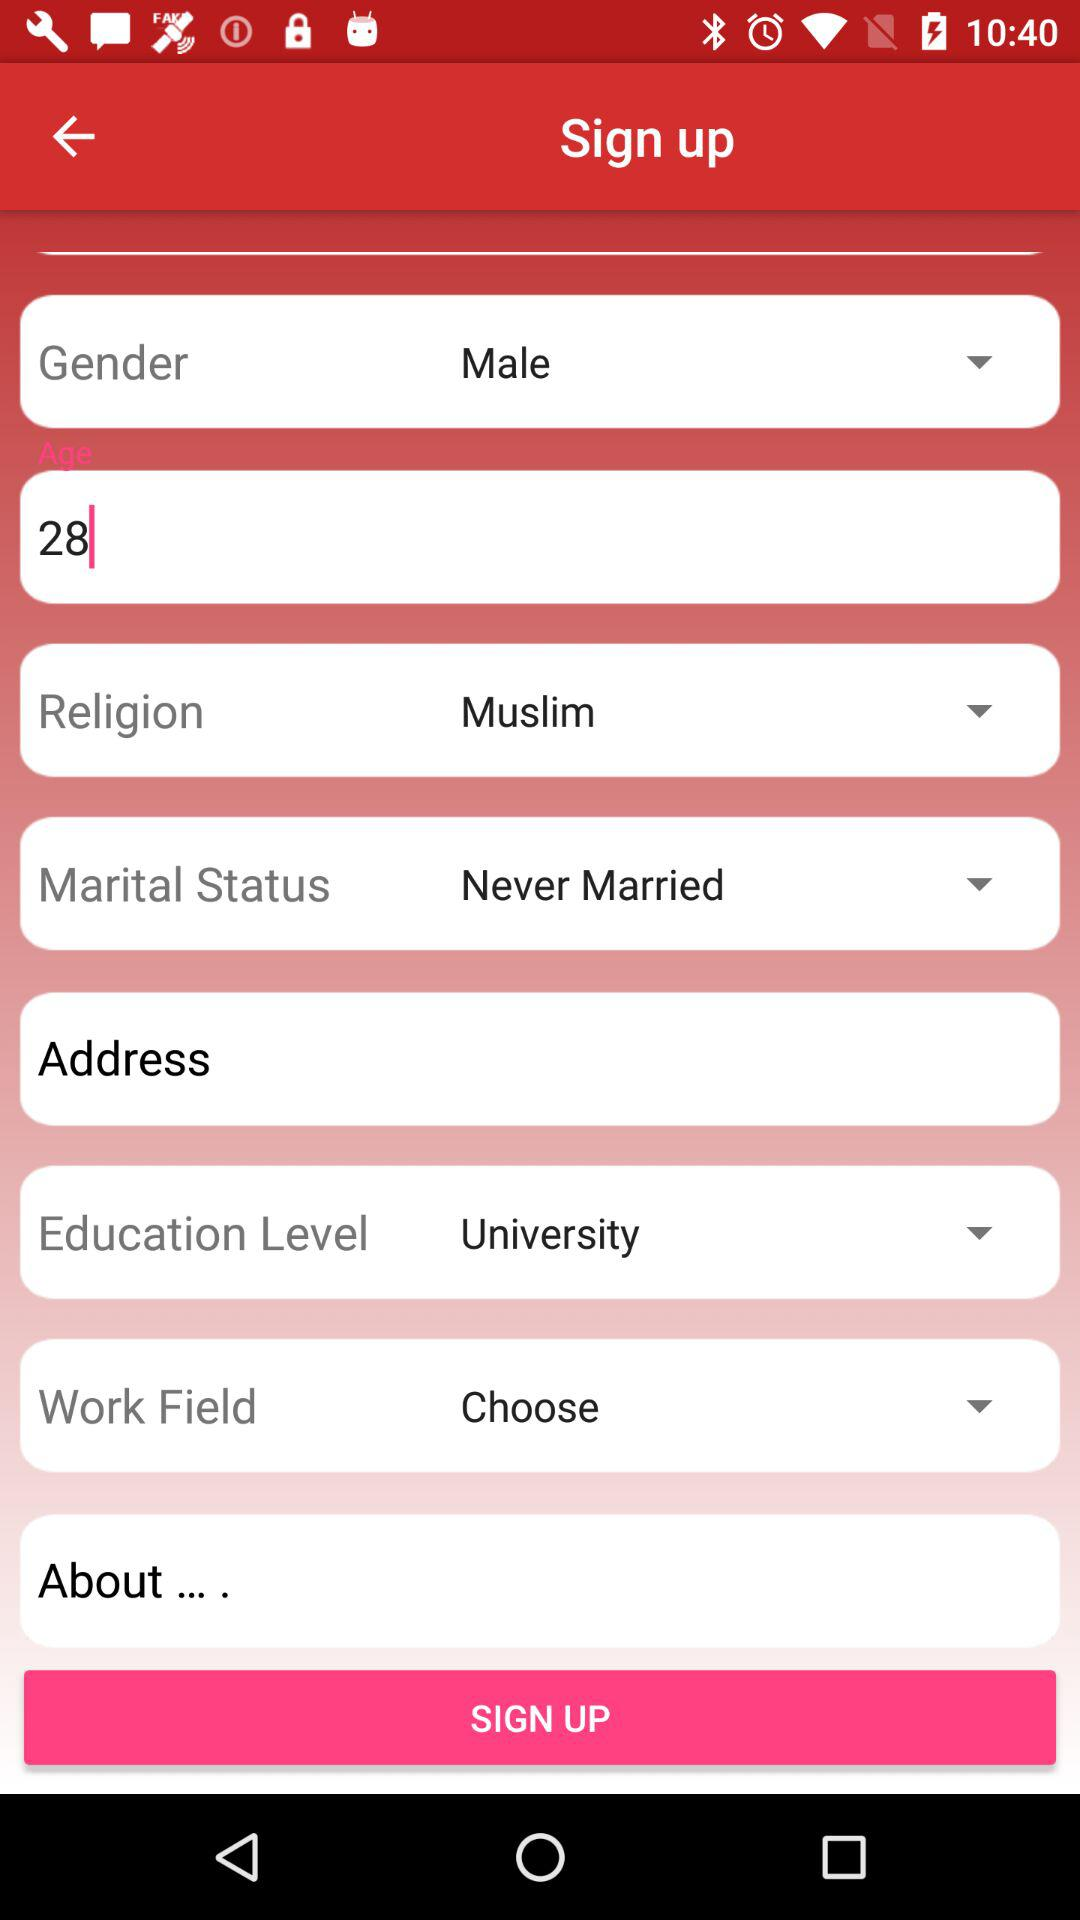What is the gender of the user? The gender of the user is male. 